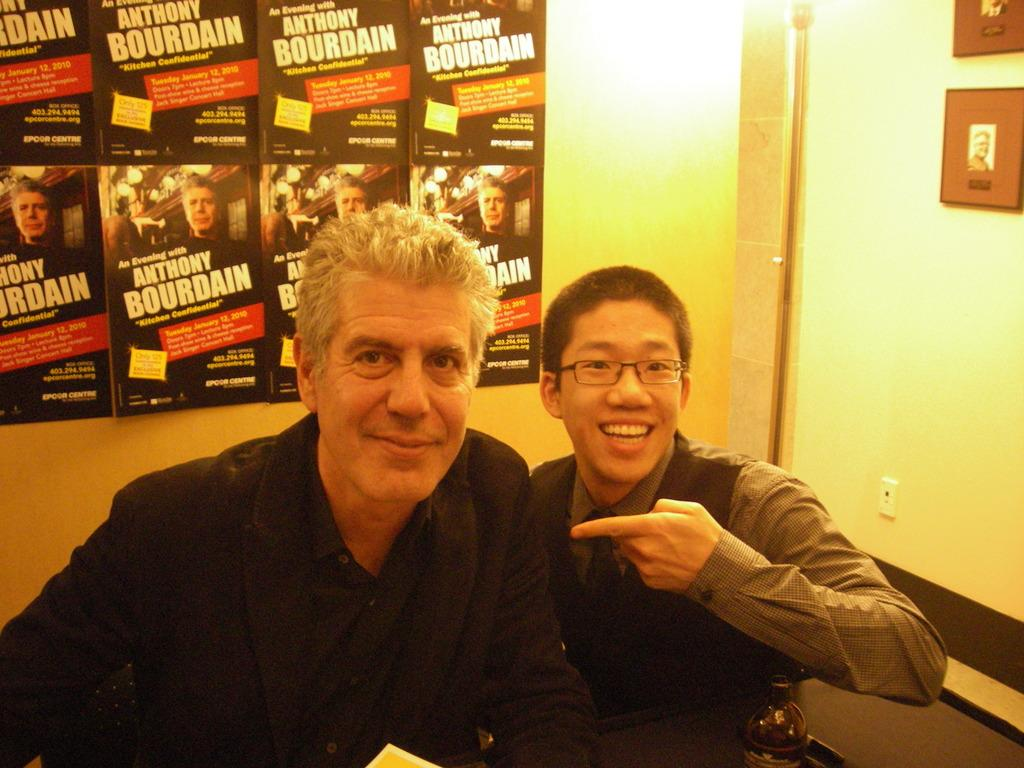How many people are in the image? There are two men in the center of the image. What can be seen in the background of the image? There are posters in the background of the image. What type of support can be seen in the image? There is no support visible in the image; it only features two men and posters in the background. 